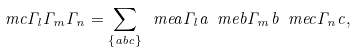<formula> <loc_0><loc_0><loc_500><loc_500>\ m c { \Gamma _ { l } } { \Gamma _ { m } } { \Gamma _ { n } } = \sum _ { \{ a b c \} } \ m e { a } { \Gamma _ { l } } { a } \ m e { b } { \Gamma _ { m } } { b } \ m e { c } { \Gamma _ { n } } { c } ,</formula> 